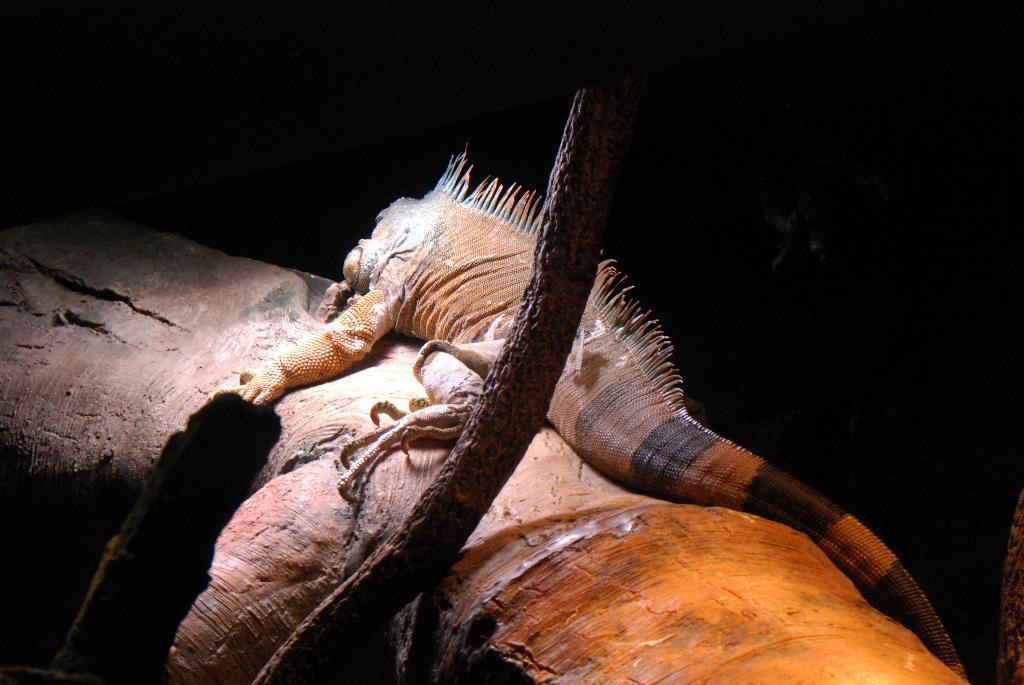How would you summarize this image in a sentence or two? In this picture we can see a reptile on an object. At the bottom of the image, there are branches. Behind the reptile, there is a dark background. 